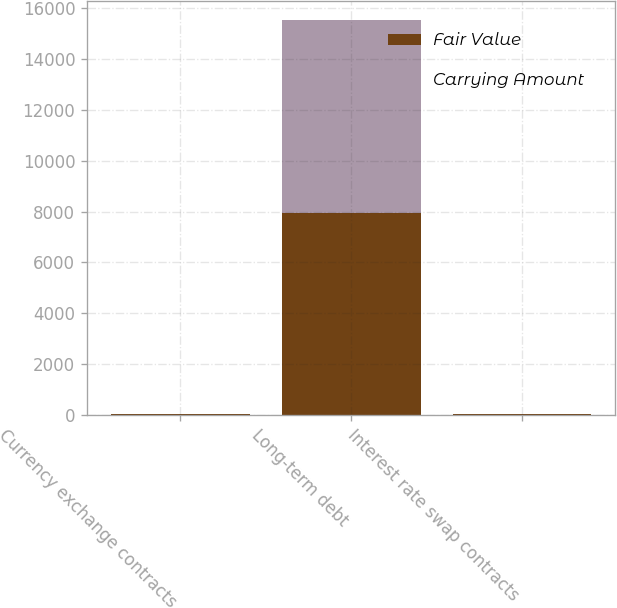Convert chart to OTSL. <chart><loc_0><loc_0><loc_500><loc_500><stacked_bar_chart><ecel><fcel>Currency exchange contracts<fcel>Long-term debt<fcel>Interest rate swap contracts<nl><fcel>Fair Value<fcel>19<fcel>7933<fcel>17<nl><fcel>Carrying Amount<fcel>19<fcel>7603<fcel>17<nl></chart> 